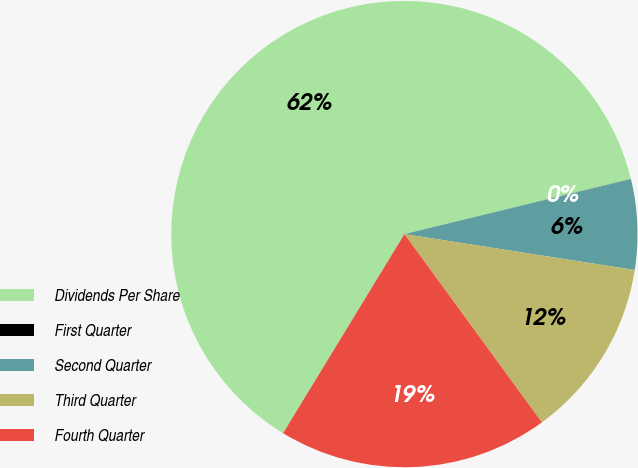<chart> <loc_0><loc_0><loc_500><loc_500><pie_chart><fcel>Dividends Per Share<fcel>First Quarter<fcel>Second Quarter<fcel>Third Quarter<fcel>Fourth Quarter<nl><fcel>62.49%<fcel>0.01%<fcel>6.25%<fcel>12.5%<fcel>18.75%<nl></chart> 